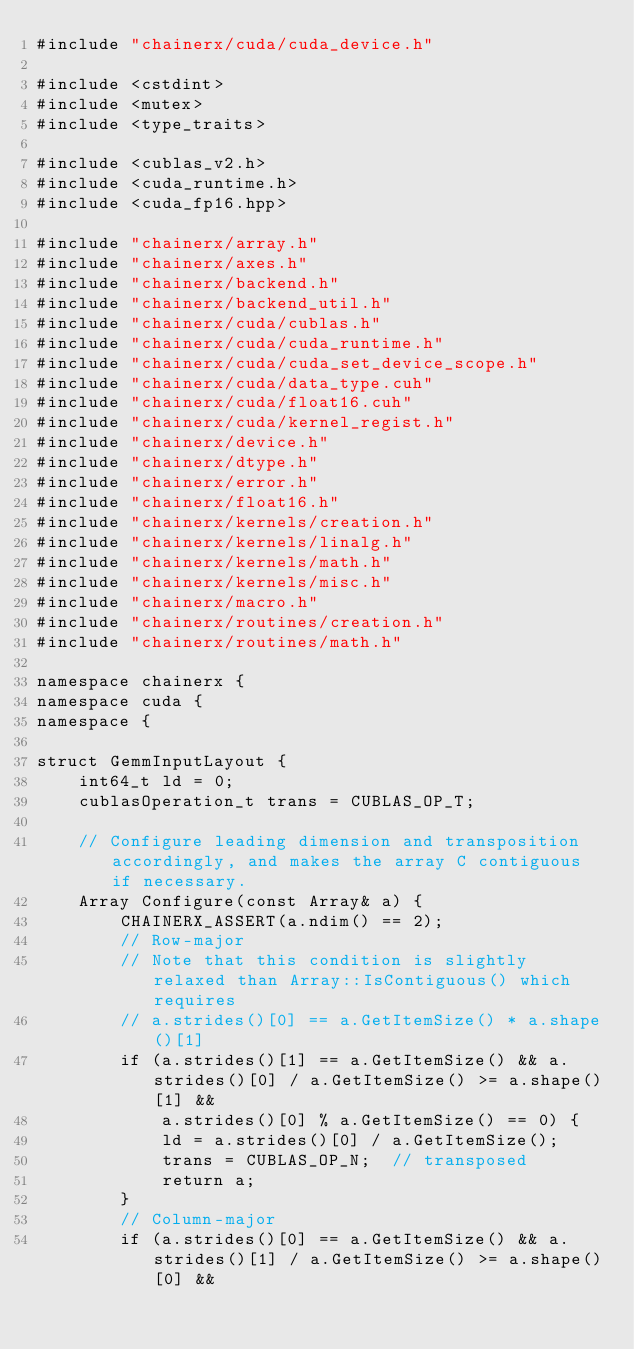<code> <loc_0><loc_0><loc_500><loc_500><_Cuda_>#include "chainerx/cuda/cuda_device.h"

#include <cstdint>
#include <mutex>
#include <type_traits>

#include <cublas_v2.h>
#include <cuda_runtime.h>
#include <cuda_fp16.hpp>

#include "chainerx/array.h"
#include "chainerx/axes.h"
#include "chainerx/backend.h"
#include "chainerx/backend_util.h"
#include "chainerx/cuda/cublas.h"
#include "chainerx/cuda/cuda_runtime.h"
#include "chainerx/cuda/cuda_set_device_scope.h"
#include "chainerx/cuda/data_type.cuh"
#include "chainerx/cuda/float16.cuh"
#include "chainerx/cuda/kernel_regist.h"
#include "chainerx/device.h"
#include "chainerx/dtype.h"
#include "chainerx/error.h"
#include "chainerx/float16.h"
#include "chainerx/kernels/creation.h"
#include "chainerx/kernels/linalg.h"
#include "chainerx/kernels/math.h"
#include "chainerx/kernels/misc.h"
#include "chainerx/macro.h"
#include "chainerx/routines/creation.h"
#include "chainerx/routines/math.h"

namespace chainerx {
namespace cuda {
namespace {

struct GemmInputLayout {
    int64_t ld = 0;
    cublasOperation_t trans = CUBLAS_OP_T;

    // Configure leading dimension and transposition accordingly, and makes the array C contiguous if necessary.
    Array Configure(const Array& a) {
        CHAINERX_ASSERT(a.ndim() == 2);
        // Row-major
        // Note that this condition is slightly relaxed than Array::IsContiguous() which requires
        // a.strides()[0] == a.GetItemSize() * a.shape()[1]
        if (a.strides()[1] == a.GetItemSize() && a.strides()[0] / a.GetItemSize() >= a.shape()[1] &&
            a.strides()[0] % a.GetItemSize() == 0) {
            ld = a.strides()[0] / a.GetItemSize();
            trans = CUBLAS_OP_N;  // transposed
            return a;
        }
        // Column-major
        if (a.strides()[0] == a.GetItemSize() && a.strides()[1] / a.GetItemSize() >= a.shape()[0] &&</code> 